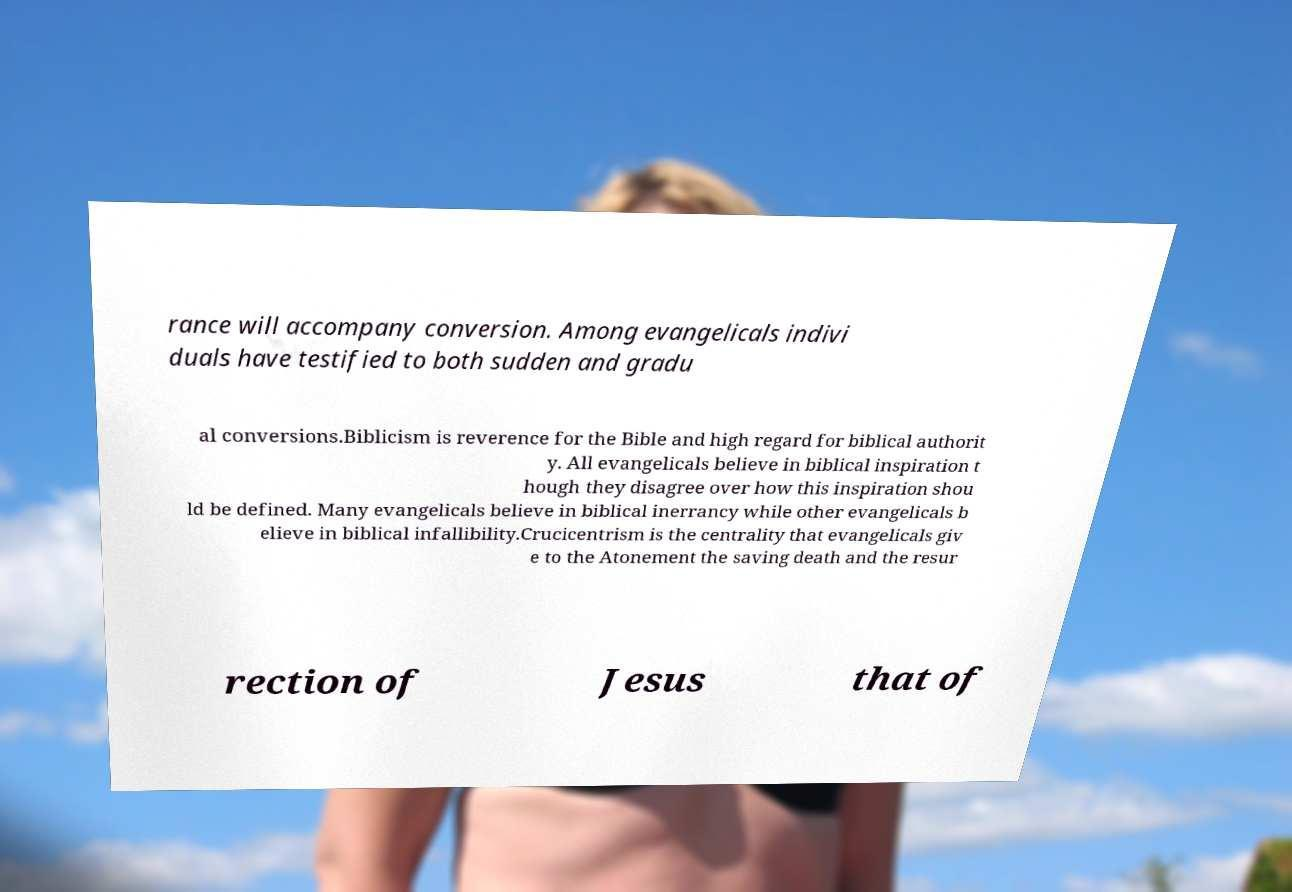For documentation purposes, I need the text within this image transcribed. Could you provide that? rance will accompany conversion. Among evangelicals indivi duals have testified to both sudden and gradu al conversions.Biblicism is reverence for the Bible and high regard for biblical authorit y. All evangelicals believe in biblical inspiration t hough they disagree over how this inspiration shou ld be defined. Many evangelicals believe in biblical inerrancy while other evangelicals b elieve in biblical infallibility.Crucicentrism is the centrality that evangelicals giv e to the Atonement the saving death and the resur rection of Jesus that of 